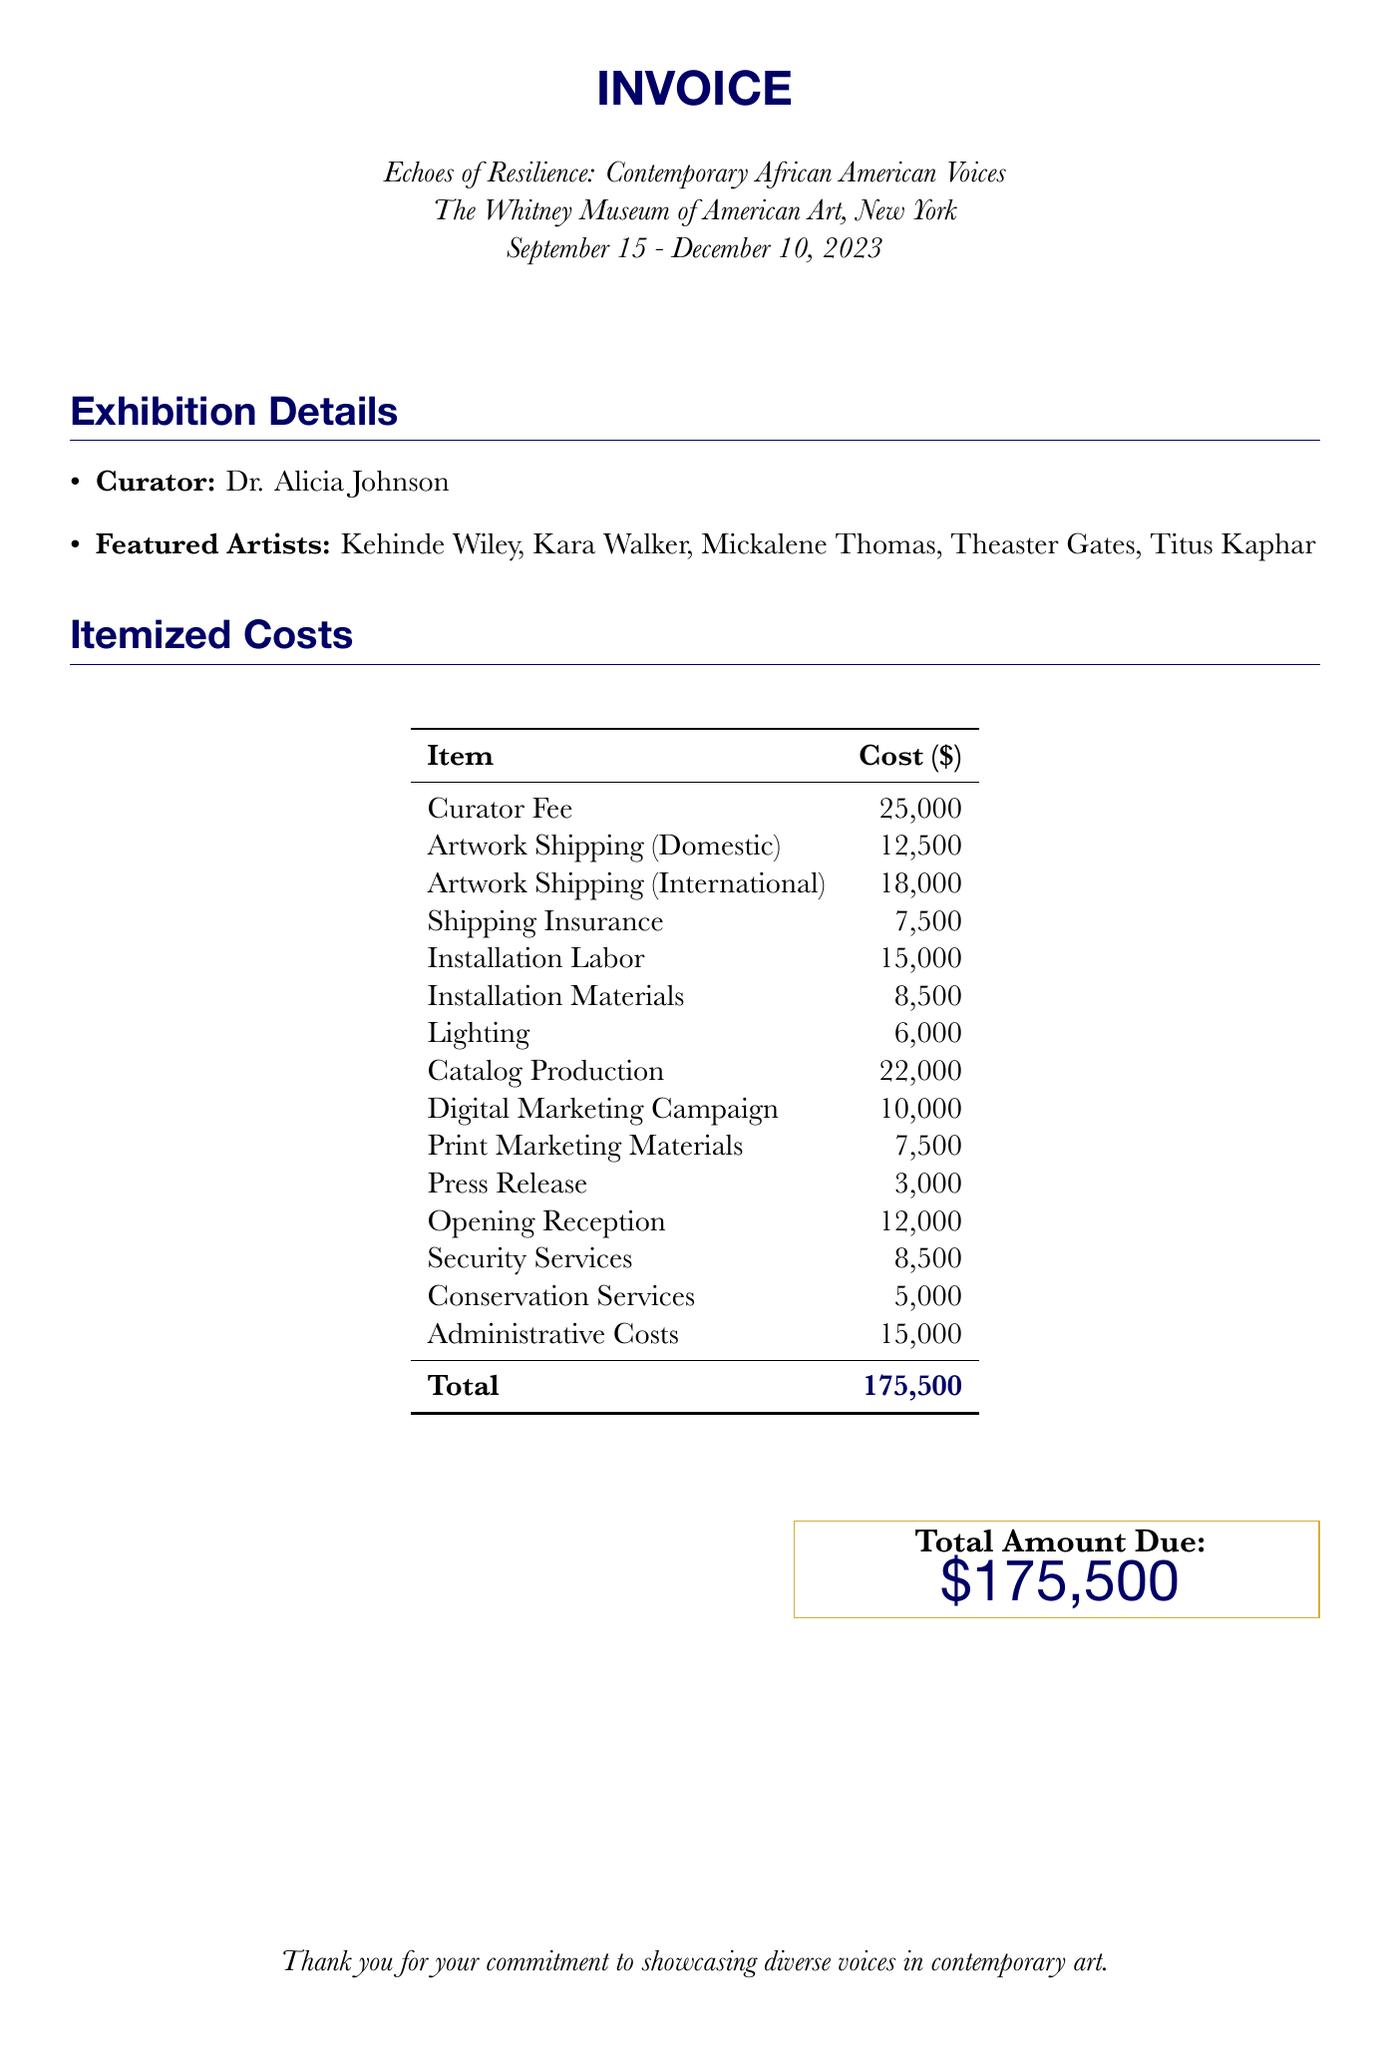What is the title of the exhibition? The title of the exhibition is prominently displayed at the top of the document.
Answer: Echoes of Resilience: Contemporary African American Voices Who is the curator of the exhibition? The curator's name is listed in the exhibition details section of the document.
Answer: Dr. Alicia Johnson How much is the curator's fee? The fee for the curator is specified in the itemized costs table.
Answer: 25,000 What is the total amount due? The total amount due is highlighted in the document, summarizing all costs.
Answer: 175,500 How much is allocated for artwork shipping (international)? This specific cost is detailed in the itemized costs section of the document.
Answer: 18,000 What is the cost for lighting? The cost for lighting is explicitly mentioned in the itemized costs table.
Answer: 6,000 Which city is the exhibition held in? The location of the exhibition is specified at the beginning of the document.
Answer: New York What service costs 5,000 dollars? This amount is found under the itemized costs, referring to conservation services.
Answer: Conservation Services How much is budgeted for the opening reception? The cost for the opening reception is clearly laid out in the itemized costs section.
Answer: 12,000 